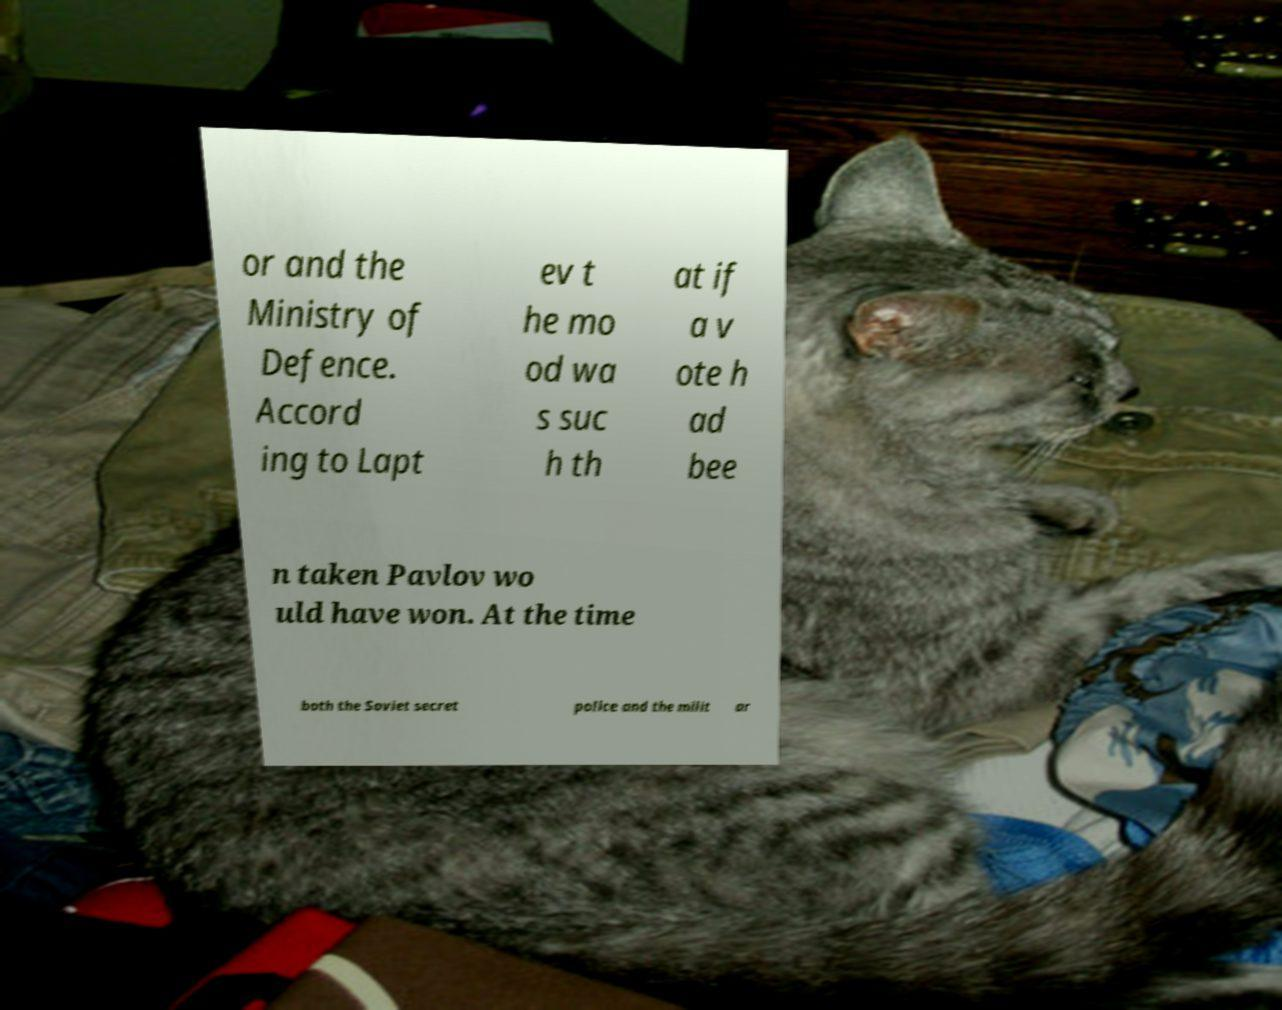Can you accurately transcribe the text from the provided image for me? or and the Ministry of Defence. Accord ing to Lapt ev t he mo od wa s suc h th at if a v ote h ad bee n taken Pavlov wo uld have won. At the time both the Soviet secret police and the milit ar 